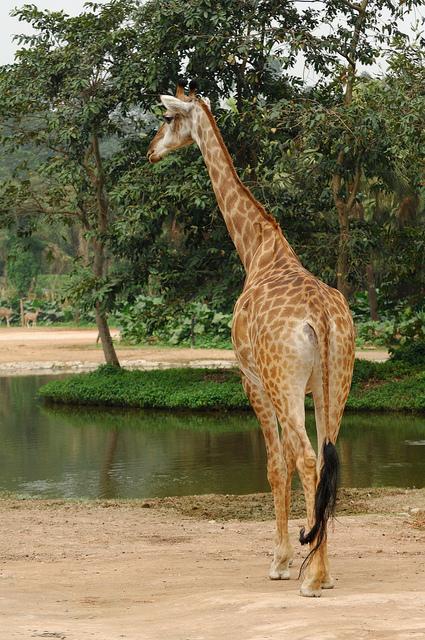How many elephants?
Give a very brief answer. 0. 